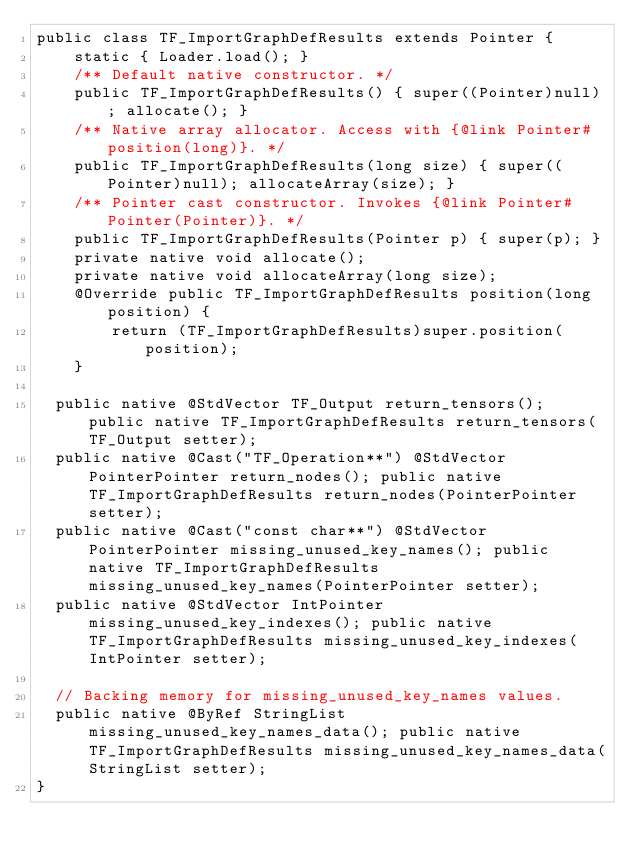Convert code to text. <code><loc_0><loc_0><loc_500><loc_500><_Java_>public class TF_ImportGraphDefResults extends Pointer {
    static { Loader.load(); }
    /** Default native constructor. */
    public TF_ImportGraphDefResults() { super((Pointer)null); allocate(); }
    /** Native array allocator. Access with {@link Pointer#position(long)}. */
    public TF_ImportGraphDefResults(long size) { super((Pointer)null); allocateArray(size); }
    /** Pointer cast constructor. Invokes {@link Pointer#Pointer(Pointer)}. */
    public TF_ImportGraphDefResults(Pointer p) { super(p); }
    private native void allocate();
    private native void allocateArray(long size);
    @Override public TF_ImportGraphDefResults position(long position) {
        return (TF_ImportGraphDefResults)super.position(position);
    }

  public native @StdVector TF_Output return_tensors(); public native TF_ImportGraphDefResults return_tensors(TF_Output setter);
  public native @Cast("TF_Operation**") @StdVector PointerPointer return_nodes(); public native TF_ImportGraphDefResults return_nodes(PointerPointer setter);
  public native @Cast("const char**") @StdVector PointerPointer missing_unused_key_names(); public native TF_ImportGraphDefResults missing_unused_key_names(PointerPointer setter);
  public native @StdVector IntPointer missing_unused_key_indexes(); public native TF_ImportGraphDefResults missing_unused_key_indexes(IntPointer setter);

  // Backing memory for missing_unused_key_names values.
  public native @ByRef StringList missing_unused_key_names_data(); public native TF_ImportGraphDefResults missing_unused_key_names_data(StringList setter);
}
</code> 